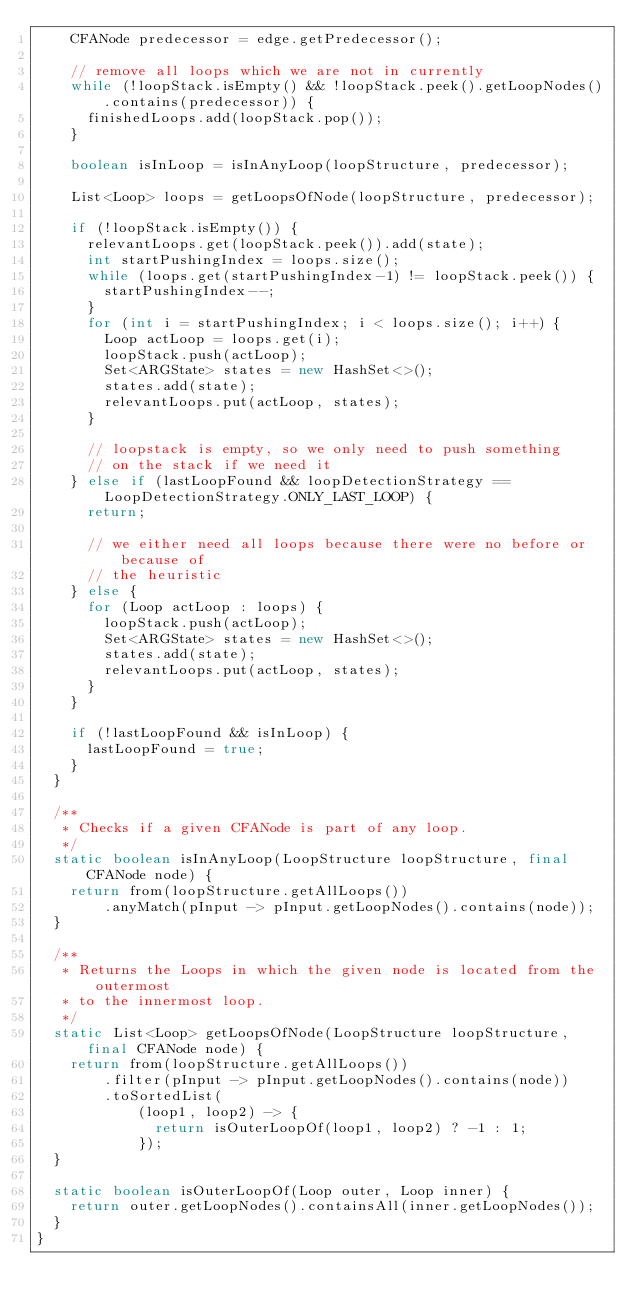<code> <loc_0><loc_0><loc_500><loc_500><_Java_>    CFANode predecessor = edge.getPredecessor();

    // remove all loops which we are not in currently
    while (!loopStack.isEmpty() && !loopStack.peek().getLoopNodes().contains(predecessor)) {
      finishedLoops.add(loopStack.pop());
    }

    boolean isInLoop = isInAnyLoop(loopStructure, predecessor);

    List<Loop> loops = getLoopsOfNode(loopStructure, predecessor);

    if (!loopStack.isEmpty()) {
      relevantLoops.get(loopStack.peek()).add(state);
      int startPushingIndex = loops.size();
      while (loops.get(startPushingIndex-1) != loopStack.peek()) {
        startPushingIndex--;
      }
      for (int i = startPushingIndex; i < loops.size(); i++) {
        Loop actLoop = loops.get(i);
        loopStack.push(actLoop);
        Set<ARGState> states = new HashSet<>();
        states.add(state);
        relevantLoops.put(actLoop, states);
      }

      // loopstack is empty, so we only need to push something
      // on the stack if we need it
    } else if (lastLoopFound && loopDetectionStrategy == LoopDetectionStrategy.ONLY_LAST_LOOP) {
      return;

      // we either need all loops because there were no before or because of
      // the heuristic
    } else {
      for (Loop actLoop : loops) {
        loopStack.push(actLoop);
        Set<ARGState> states = new HashSet<>();
        states.add(state);
        relevantLoops.put(actLoop, states);
      }
    }

    if (!lastLoopFound && isInLoop) {
      lastLoopFound = true;
    }
  }

  /**
   * Checks if a given CFANode is part of any loop.
   */
  static boolean isInAnyLoop(LoopStructure loopStructure, final CFANode node) {
    return from(loopStructure.getAllLoops())
        .anyMatch(pInput -> pInput.getLoopNodes().contains(node));
  }

  /**
   * Returns the Loops in which the given node is located from the outermost
   * to the innermost loop.
   */
  static List<Loop> getLoopsOfNode(LoopStructure loopStructure, final CFANode node) {
    return from(loopStructure.getAllLoops())
        .filter(pInput -> pInput.getLoopNodes().contains(node))
        .toSortedList(
            (loop1, loop2) -> {
              return isOuterLoopOf(loop1, loop2) ? -1 : 1;
            });
  }

  static boolean isOuterLoopOf(Loop outer, Loop inner) {
    return outer.getLoopNodes().containsAll(inner.getLoopNodes());
  }
}
</code> 